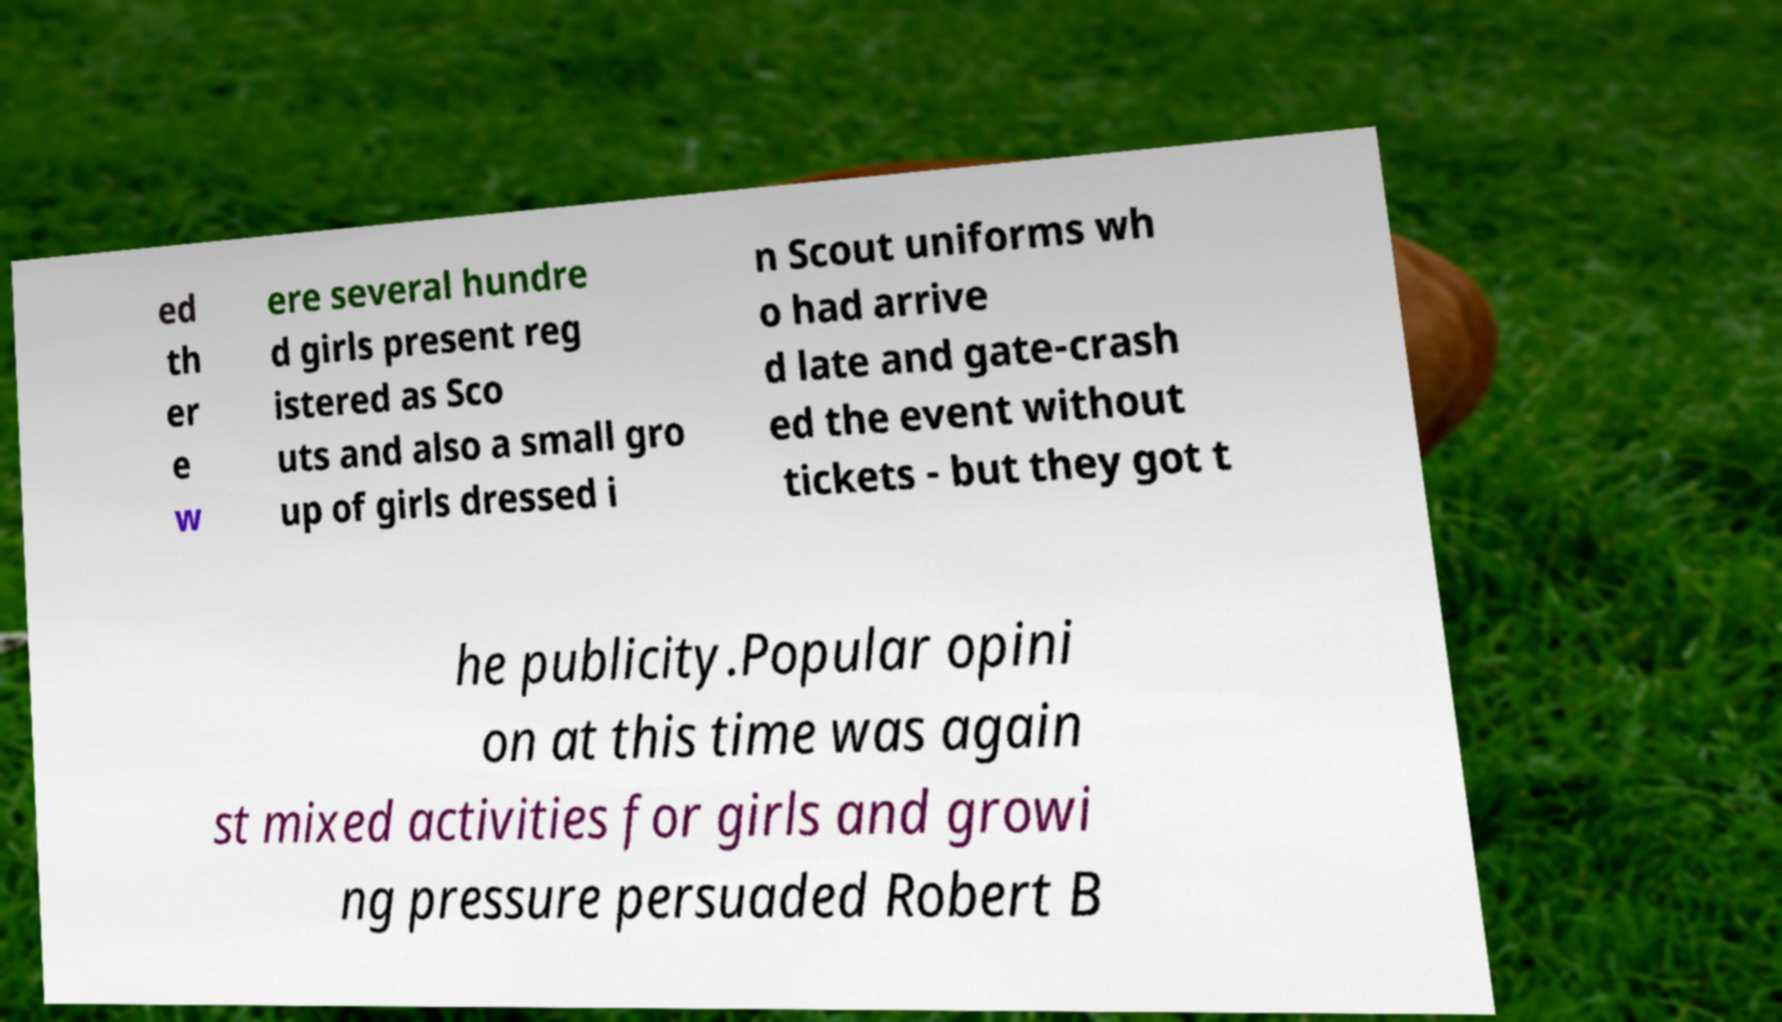I need the written content from this picture converted into text. Can you do that? ed th er e w ere several hundre d girls present reg istered as Sco uts and also a small gro up of girls dressed i n Scout uniforms wh o had arrive d late and gate-crash ed the event without tickets - but they got t he publicity.Popular opini on at this time was again st mixed activities for girls and growi ng pressure persuaded Robert B 